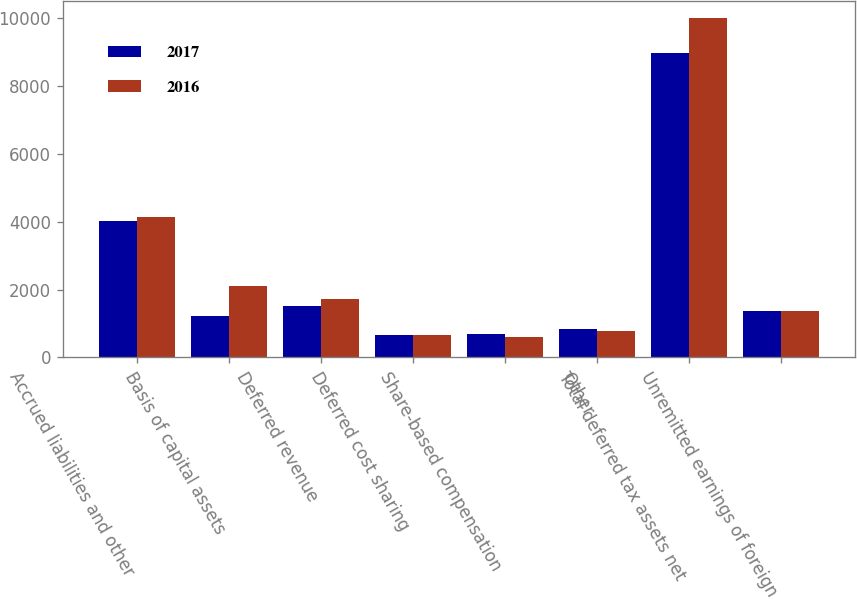Convert chart to OTSL. <chart><loc_0><loc_0><loc_500><loc_500><stacked_bar_chart><ecel><fcel>Accrued liabilities and other<fcel>Basis of capital assets<fcel>Deferred revenue<fcel>Deferred cost sharing<fcel>Share-based compensation<fcel>Other<fcel>Total deferred tax assets net<fcel>Unremitted earnings of foreign<nl><fcel>2017<fcel>4019<fcel>1230<fcel>1521<fcel>667<fcel>703<fcel>834<fcel>8974<fcel>1375.5<nl><fcel>2016<fcel>4135<fcel>2107<fcel>1717<fcel>667<fcel>601<fcel>788<fcel>10015<fcel>1375.5<nl></chart> 